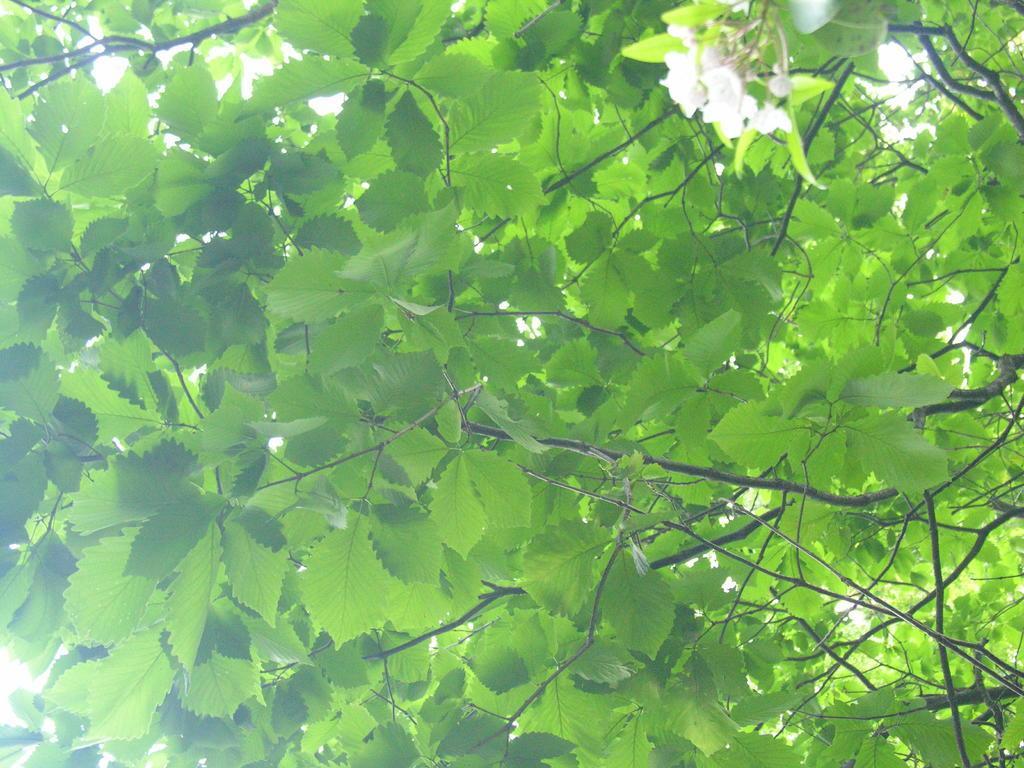How would you summarize this image in a sentence or two? In this picture we can see some flowers to the trees. 